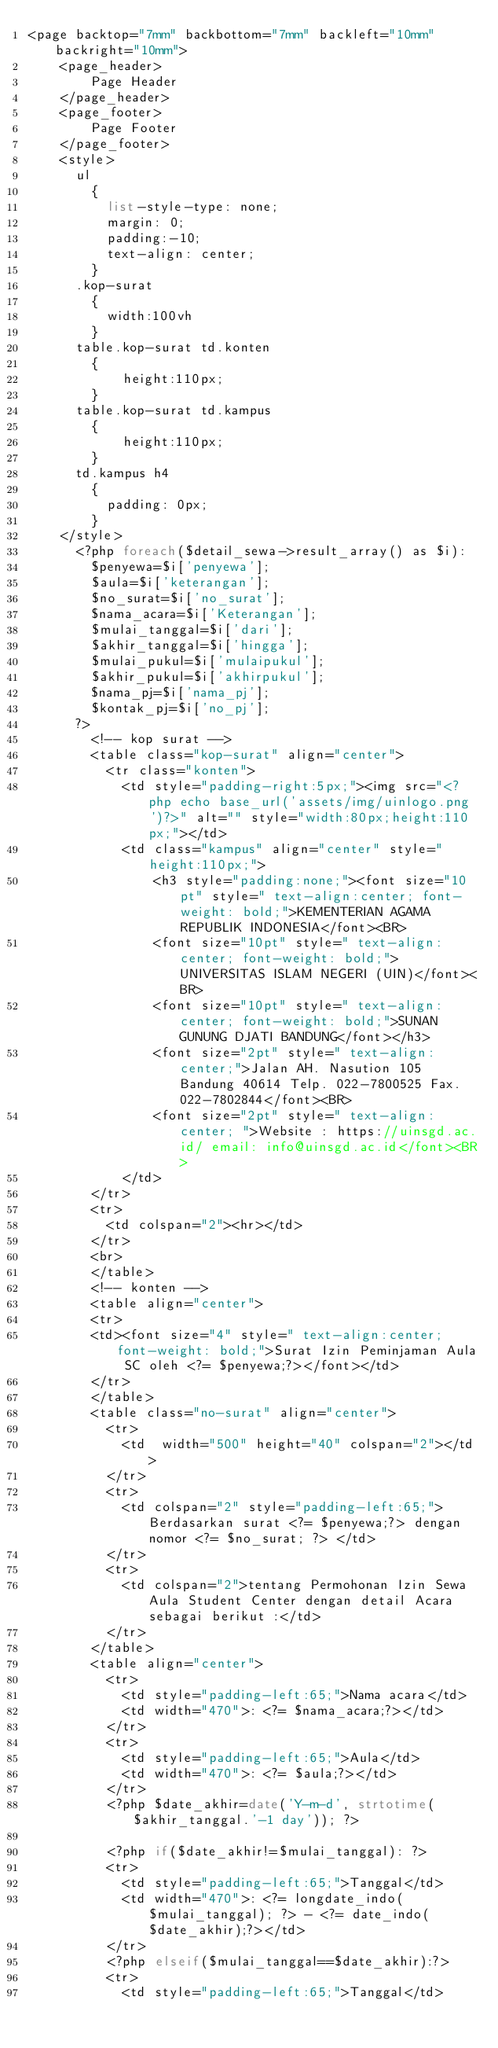<code> <loc_0><loc_0><loc_500><loc_500><_PHP_><page backtop="7mm" backbottom="7mm" backleft="10mm" backright="10mm"> 
    <page_header> 
        Page Header 
    </page_header> 
    <page_footer> 
        Page Footer 
    </page_footer>
    <style>
      ul 
        {
          list-style-type: none;
          margin: 0;
          padding:-10;
          text-align: center;
        }
      .kop-surat
        {
          width:100vh
        }
      table.kop-surat td.konten
        {
            height:110px;
        }
      table.kop-surat td.kampus
        {
            height:110px;
        }
      td.kampus h4
        {
          padding: 0px;
        }
    </style>
      <?php foreach($detail_sewa->result_array() as $i):
        $penyewa=$i['penyewa'];
        $aula=$i['keterangan'];
        $no_surat=$i['no_surat'];
        $nama_acara=$i['Keterangan'];
        $mulai_tanggal=$i['dari'];
        $akhir_tanggal=$i['hingga'];
        $mulai_pukul=$i['mulaipukul'];
        $akhir_pukul=$i['akhirpukul'];
        $nama_pj=$i['nama_pj'];
        $kontak_pj=$i['no_pj'];
      ?>
        <!-- kop surat -->
        <table class="kop-surat" align="center">
          <tr class="konten">
            <td style="padding-right:5px;"><img src="<?php echo base_url('assets/img/uinlogo.png')?>" alt="" style="width:80px;height:110px;"></td>
            <td class="kampus" align="center" style="height:110px;">
                <h3 style="padding:none;"><font size="10pt" style=" text-align:center; font-weight: bold;">KEMENTERIAN AGAMA REPUBLIK INDONESIA</font><BR>
                <font size="10pt" style=" text-align:center; font-weight: bold;">UNIVERSITAS ISLAM NEGERI (UIN)</font><BR>
                <font size="10pt" style=" text-align:center; font-weight: bold;">SUNAN GUNUNG DJATI BANDUNG</font></h3>
                <font size="2pt" style=" text-align:center;">Jalan AH. Nasution 105 Bandung 40614 Telp. 022-7800525 Fax. 022-7802844</font><BR>
                <font size="2pt" style=" text-align:center; ">Website : https://uinsgd.ac.id/ email: info@uinsgd.ac.id</font><BR>
            </td>
        </tr>
        <tr>
          <td colspan="2"><hr></td>
        </tr>
        <br>
        </table>
        <!-- konten -->
        <table align="center">
        <tr>
        <td><font size="4" style=" text-align:center; font-weight: bold;">Surat Izin Peminjaman Aula SC oleh <?= $penyewa;?></font></td>
        </tr>
        </table>
        <table class="no-surat" align="center">
          <tr>
            <td  width="500" height="40" colspan="2"></td>
          </tr>
          <tr>
            <td colspan="2" style="padding-left:65;">Berdasarkan surat <?= $penyewa;?> dengan nomor <?= $no_surat; ?> </td>
          </tr>
          <tr>
            <td colspan="2">tentang Permohonan Izin Sewa Aula Student Center dengan detail Acara sebagai berikut :</td>
          </tr>
        </table>
        <table align="center">
          <tr> 
            <td style="padding-left:65;">Nama acara</td>
            <td width="470">: <?= $nama_acara;?></td>
          </tr>
          <tr> 
            <td style="padding-left:65;">Aula</td>
            <td width="470">: <?= $aula;?></td>
          </tr>
          <?php $date_akhir=date('Y-m-d', strtotime($akhir_tanggal.'-1 day')); ?>
          
          <?php if($date_akhir!=$mulai_tanggal): ?>
          <tr> 
            <td style="padding-left:65;">Tanggal</td>
            <td width="470">: <?= longdate_indo($mulai_tanggal); ?> - <?= date_indo($date_akhir);?></td>
          </tr>
          <?php elseif($mulai_tanggal==$date_akhir):?>
          <tr> 
            <td style="padding-left:65;">Tanggal</td></code> 